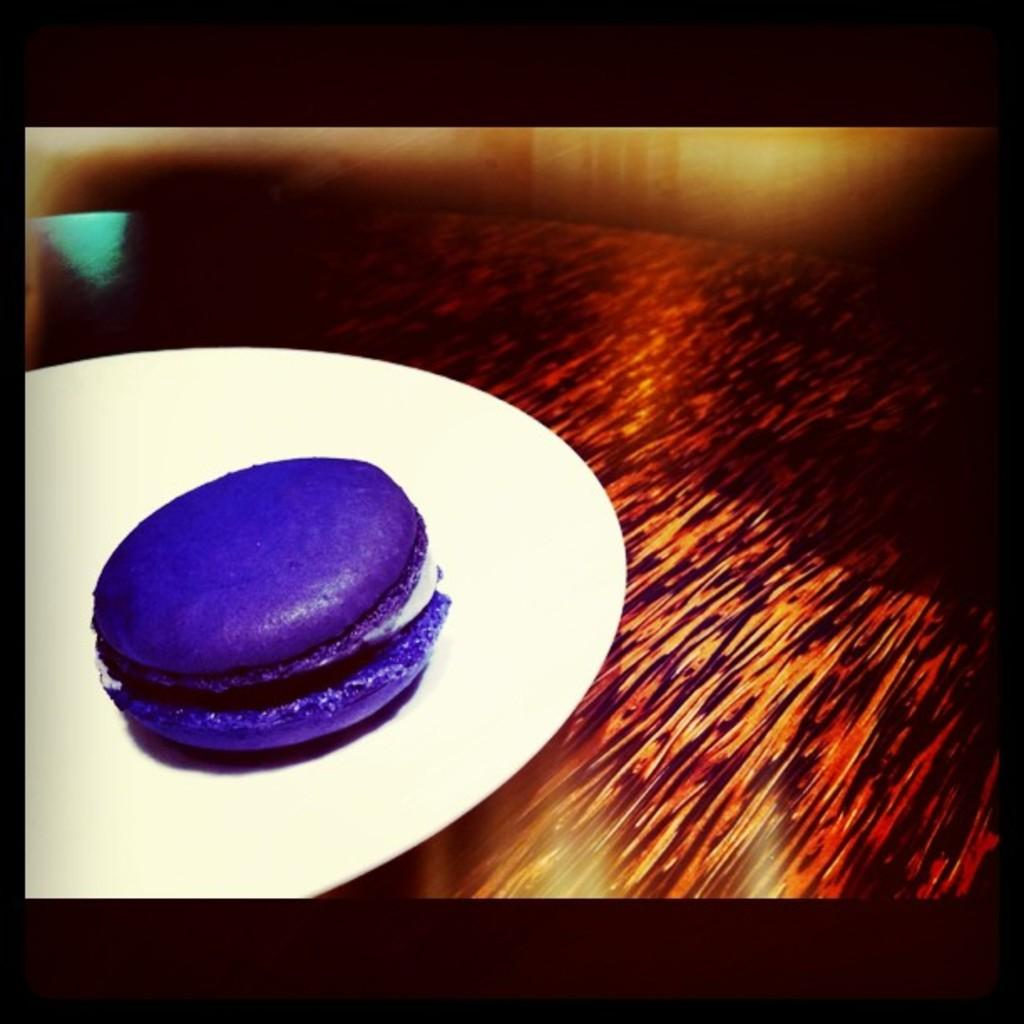What feature surrounds the main content of the image? The image has borders. What type of furniture is present in the image? There is a table in the image. What is placed on the table? There is a plate on the table. What can be found on the plate? There is a food item on the plate. What type of hat is the scarecrow wearing in the image? There is no scarecrow or hat present in the image. How does the acoustics of the room affect the sound of the food item on the plate? The acoustics of the room are not mentioned in the image, and the food item on the plate does not produce sound. 